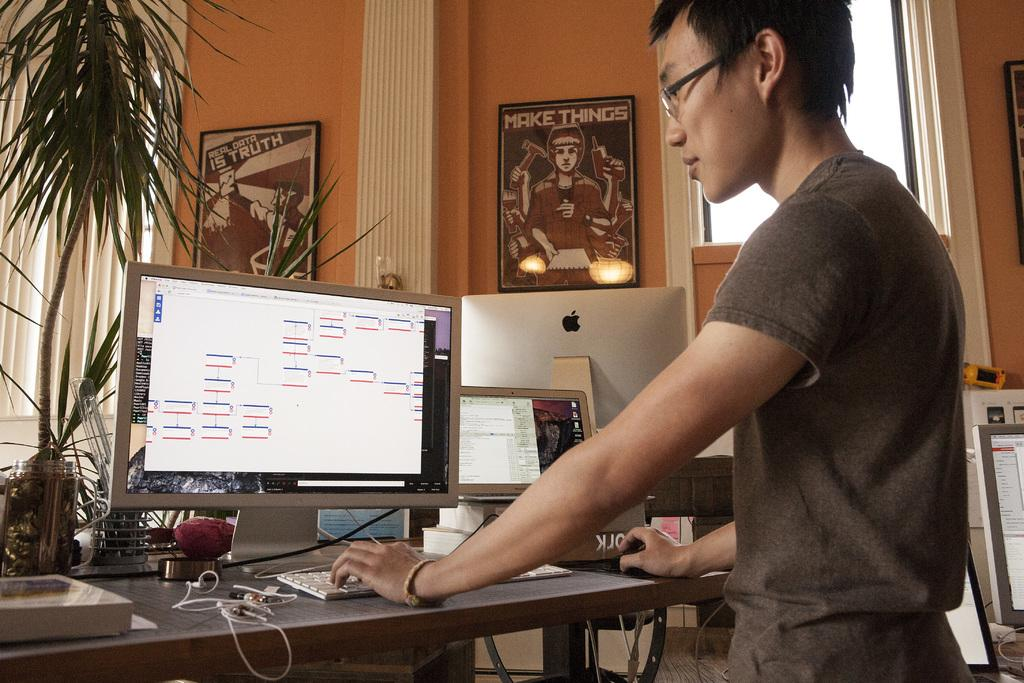What can be seen on the wall in the image? There is a plant on the wall in the image. What is the man in the image doing? There is a man standing in the image. What is on the table in the image? There are laptops, a keyboard, and a book on the table in the image. What type of behavior is the man exhibiting in the image? There is no indication of the man's behavior in the image, as it only shows him standing. Can you hear the man coughing in the image? The image is silent, and there is no indication of the man coughing. 